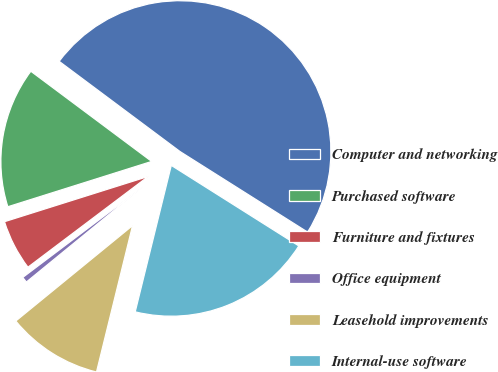Convert chart to OTSL. <chart><loc_0><loc_0><loc_500><loc_500><pie_chart><fcel>Computer and networking<fcel>Purchased software<fcel>Furniture and fixtures<fcel>Office equipment<fcel>Leasehold improvements<fcel>Internal-use software<nl><fcel>48.76%<fcel>15.06%<fcel>5.43%<fcel>0.62%<fcel>10.25%<fcel>19.88%<nl></chart> 